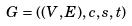<formula> <loc_0><loc_0><loc_500><loc_500>G = ( ( V , E ) , c , s , t )</formula> 